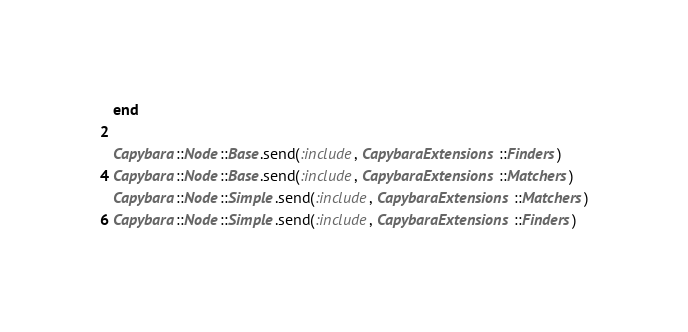<code> <loc_0><loc_0><loc_500><loc_500><_Ruby_>end

Capybara::Node::Base.send(:include, CapybaraExtensions::Finders)
Capybara::Node::Base.send(:include, CapybaraExtensions::Matchers)
Capybara::Node::Simple.send(:include, CapybaraExtensions::Matchers)
Capybara::Node::Simple.send(:include, CapybaraExtensions::Finders)
</code> 